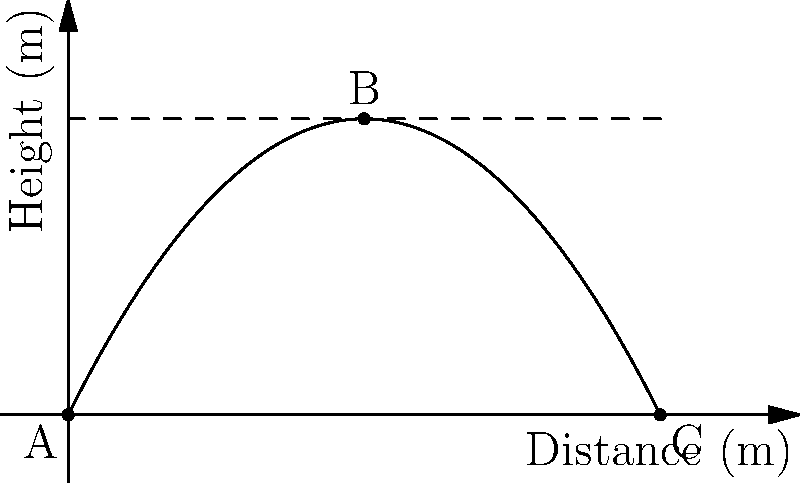In the diagram above, a ball is thrown from point A and follows a parabolic path, reaching its maximum height at point B before landing at point C. If the horizontal distance between A and C is 10 meters, and the maximum height reached is 5 meters, what is the time taken for the ball to travel from A to C? Assume the acceleration due to gravity is 9.8 m/s². To solve this problem, we'll follow these steps:

1) First, we need to understand that the motion of the ball can be split into horizontal and vertical components.

2) The horizontal motion is uniform, while the vertical motion is uniformly accelerated due to gravity.

3) We can use the equation for the time of flight:
   $$t = \sqrt{\frac{2h}{g}}$$
   Where $t$ is the time, $h$ is the maximum height, and $g$ is the acceleration due to gravity.

4) Substituting our values:
   $$t = \sqrt{\frac{2 \times 5}{9.8}} = \sqrt{\frac{10}{9.8}} = \sqrt{1.0204} = 1.01 \text{ seconds}$$

5) However, this is only the time for half the journey (from A to B). The total time will be twice this:
   $$\text{Total time} = 2 \times 1.01 = 2.02 \text{ seconds}$$

6) We can verify this using the horizontal distance equation:
   $$d = v_x \times t$$
   Where $d$ is the distance (10 m), $v_x$ is the horizontal velocity, and $t$ is the time (2.02 s).

7) Rearranging to find $v_x$:
   $$v_x = \frac{d}{t} = \frac{10}{2.02} = 4.95 \text{ m/s}$$

This horizontal velocity seems reasonable for a thrown ball, confirming our calculation.
Answer: 2.02 seconds 